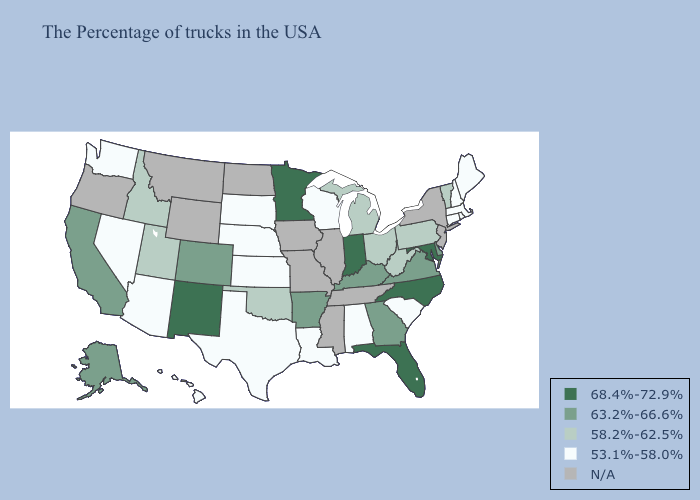Which states have the lowest value in the USA?
Short answer required. Maine, Massachusetts, Rhode Island, New Hampshire, Connecticut, South Carolina, Alabama, Wisconsin, Louisiana, Kansas, Nebraska, Texas, South Dakota, Arizona, Nevada, Washington, Hawaii. What is the lowest value in the South?
Be succinct. 53.1%-58.0%. Does Oklahoma have the lowest value in the USA?
Write a very short answer. No. Among the states that border New Mexico , does Utah have the highest value?
Quick response, please. No. What is the lowest value in the South?
Write a very short answer. 53.1%-58.0%. Among the states that border Texas , does New Mexico have the lowest value?
Answer briefly. No. What is the lowest value in the Northeast?
Answer briefly. 53.1%-58.0%. What is the highest value in the USA?
Write a very short answer. 68.4%-72.9%. What is the value of Washington?
Answer briefly. 53.1%-58.0%. Name the states that have a value in the range 68.4%-72.9%?
Short answer required. Maryland, North Carolina, Florida, Indiana, Minnesota, New Mexico. What is the lowest value in states that border Ohio?
Answer briefly. 58.2%-62.5%. What is the value of Massachusetts?
Write a very short answer. 53.1%-58.0%. How many symbols are there in the legend?
Write a very short answer. 5. Name the states that have a value in the range 63.2%-66.6%?
Short answer required. Delaware, Virginia, Georgia, Kentucky, Arkansas, Colorado, California, Alaska. 